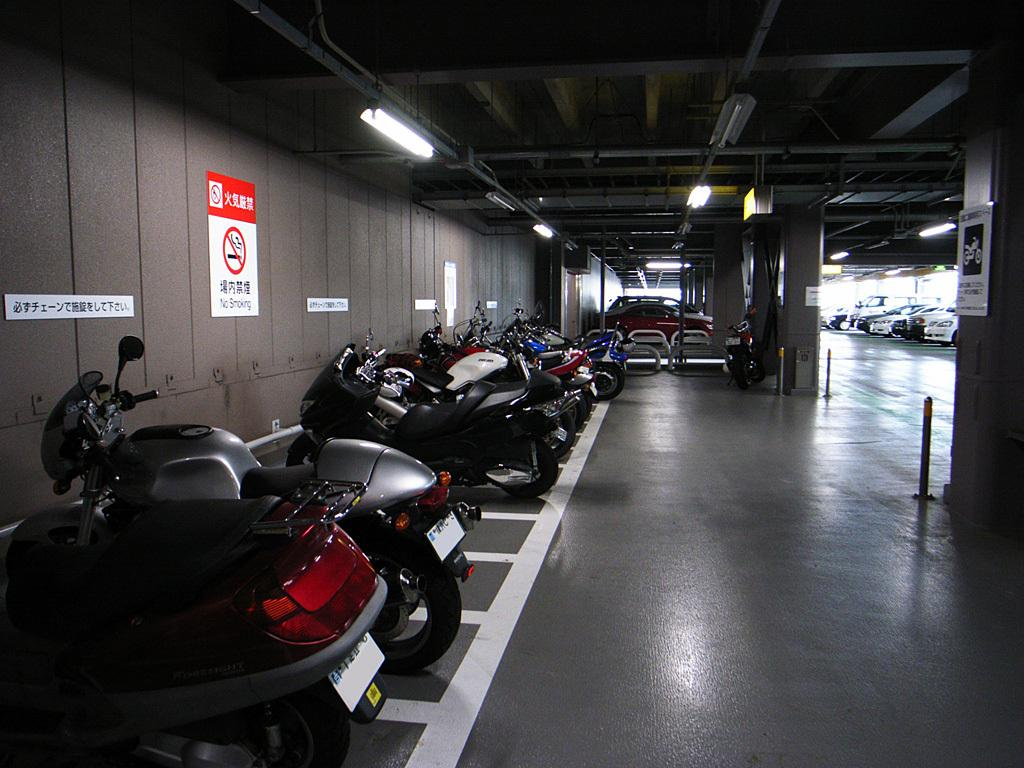What type of vehicles can be seen in the image? There are motorcycles in the image. Can you describe any other vehicles present in the image? There are other vehicles visible in the image. What is on the wall in the image? There are posters and signboards on the wall. What can be seen in the sky in the image? There are lights visible in the image. What part of a building is visible in the image? The rooftop is visible in the image. How many pickles are on the motorcycles in the image? There are no pickles present in the image; it features motorcycles and other vehicles. What type of temper can be seen in the image? There is no temper visible in the image; it features motorcycles, vehicles, posters, signboards, lights, and a rooftop. 